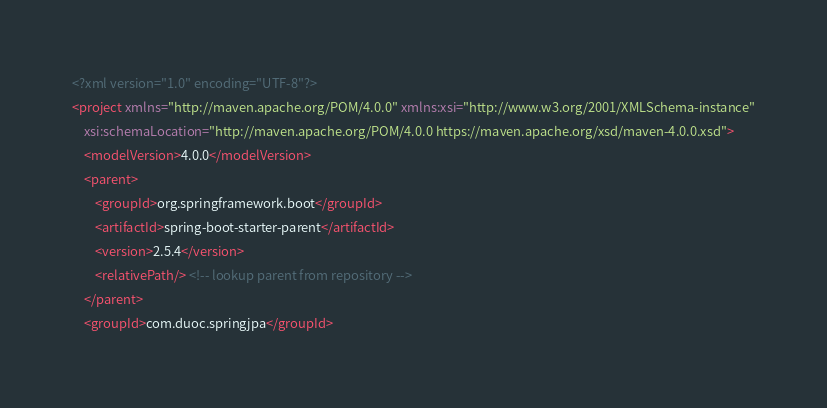<code> <loc_0><loc_0><loc_500><loc_500><_XML_><?xml version="1.0" encoding="UTF-8"?>
<project xmlns="http://maven.apache.org/POM/4.0.0" xmlns:xsi="http://www.w3.org/2001/XMLSchema-instance"
	xsi:schemaLocation="http://maven.apache.org/POM/4.0.0 https://maven.apache.org/xsd/maven-4.0.0.xsd">
	<modelVersion>4.0.0</modelVersion>
	<parent>
		<groupId>org.springframework.boot</groupId>
		<artifactId>spring-boot-starter-parent</artifactId>
		<version>2.5.4</version>
		<relativePath/> <!-- lookup parent from repository -->
	</parent>
	<groupId>com.duoc.springjpa</groupId></code> 